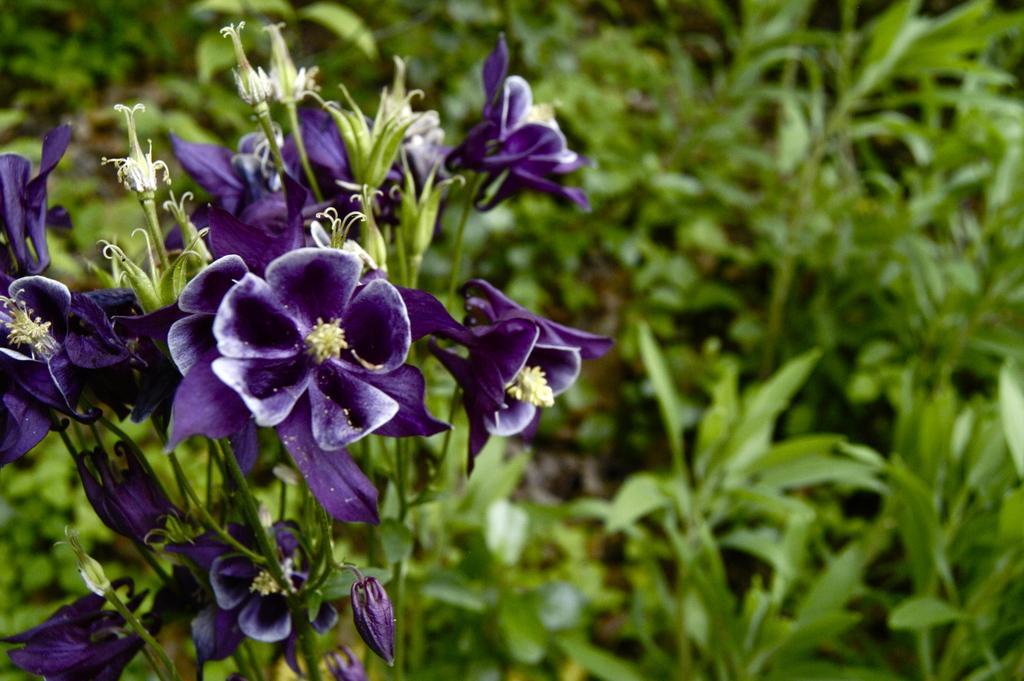Describe this image in one or two sentences. In the foreground of the pictures there are flowers and a plant. The background is blurred. In the background there is greenery. 